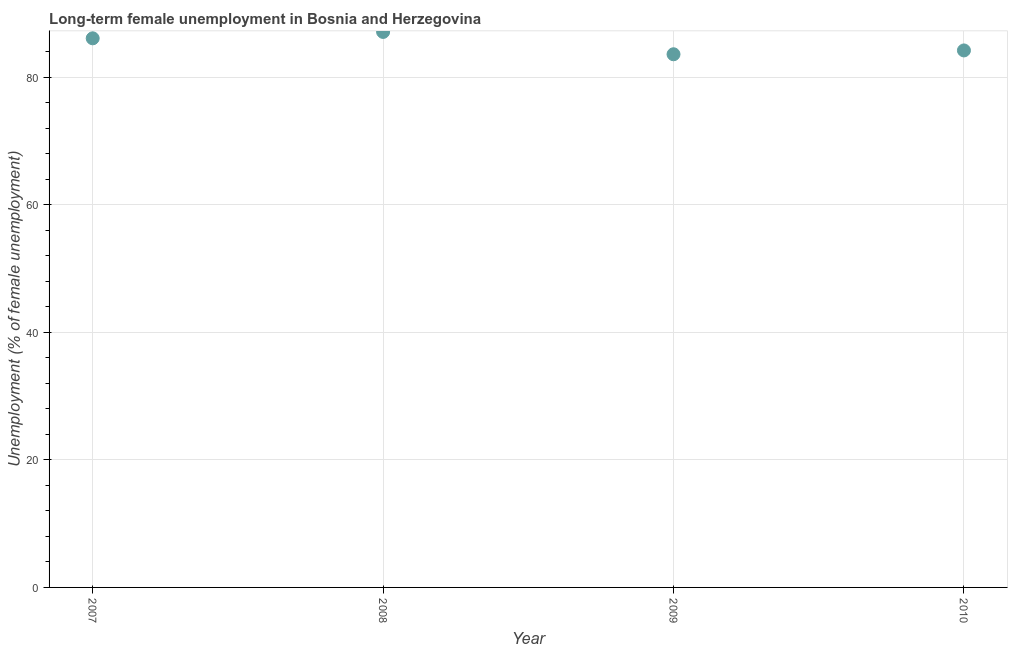What is the long-term female unemployment in 2007?
Ensure brevity in your answer.  86.1. Across all years, what is the maximum long-term female unemployment?
Give a very brief answer. 87.1. Across all years, what is the minimum long-term female unemployment?
Your answer should be compact. 83.6. What is the sum of the long-term female unemployment?
Provide a short and direct response. 341. What is the average long-term female unemployment per year?
Make the answer very short. 85.25. What is the median long-term female unemployment?
Give a very brief answer. 85.15. In how many years, is the long-term female unemployment greater than 80 %?
Make the answer very short. 4. What is the ratio of the long-term female unemployment in 2008 to that in 2009?
Offer a terse response. 1.04. Is the sum of the long-term female unemployment in 2008 and 2009 greater than the maximum long-term female unemployment across all years?
Offer a very short reply. Yes. In how many years, is the long-term female unemployment greater than the average long-term female unemployment taken over all years?
Your response must be concise. 2. How many years are there in the graph?
Give a very brief answer. 4. What is the difference between two consecutive major ticks on the Y-axis?
Provide a short and direct response. 20. Are the values on the major ticks of Y-axis written in scientific E-notation?
Your answer should be compact. No. What is the title of the graph?
Your answer should be very brief. Long-term female unemployment in Bosnia and Herzegovina. What is the label or title of the Y-axis?
Offer a very short reply. Unemployment (% of female unemployment). What is the Unemployment (% of female unemployment) in 2007?
Ensure brevity in your answer.  86.1. What is the Unemployment (% of female unemployment) in 2008?
Ensure brevity in your answer.  87.1. What is the Unemployment (% of female unemployment) in 2009?
Your answer should be very brief. 83.6. What is the Unemployment (% of female unemployment) in 2010?
Offer a very short reply. 84.2. What is the difference between the Unemployment (% of female unemployment) in 2007 and 2008?
Give a very brief answer. -1. What is the ratio of the Unemployment (% of female unemployment) in 2007 to that in 2009?
Give a very brief answer. 1.03. What is the ratio of the Unemployment (% of female unemployment) in 2008 to that in 2009?
Provide a short and direct response. 1.04. What is the ratio of the Unemployment (% of female unemployment) in 2008 to that in 2010?
Your response must be concise. 1.03. What is the ratio of the Unemployment (% of female unemployment) in 2009 to that in 2010?
Provide a short and direct response. 0.99. 